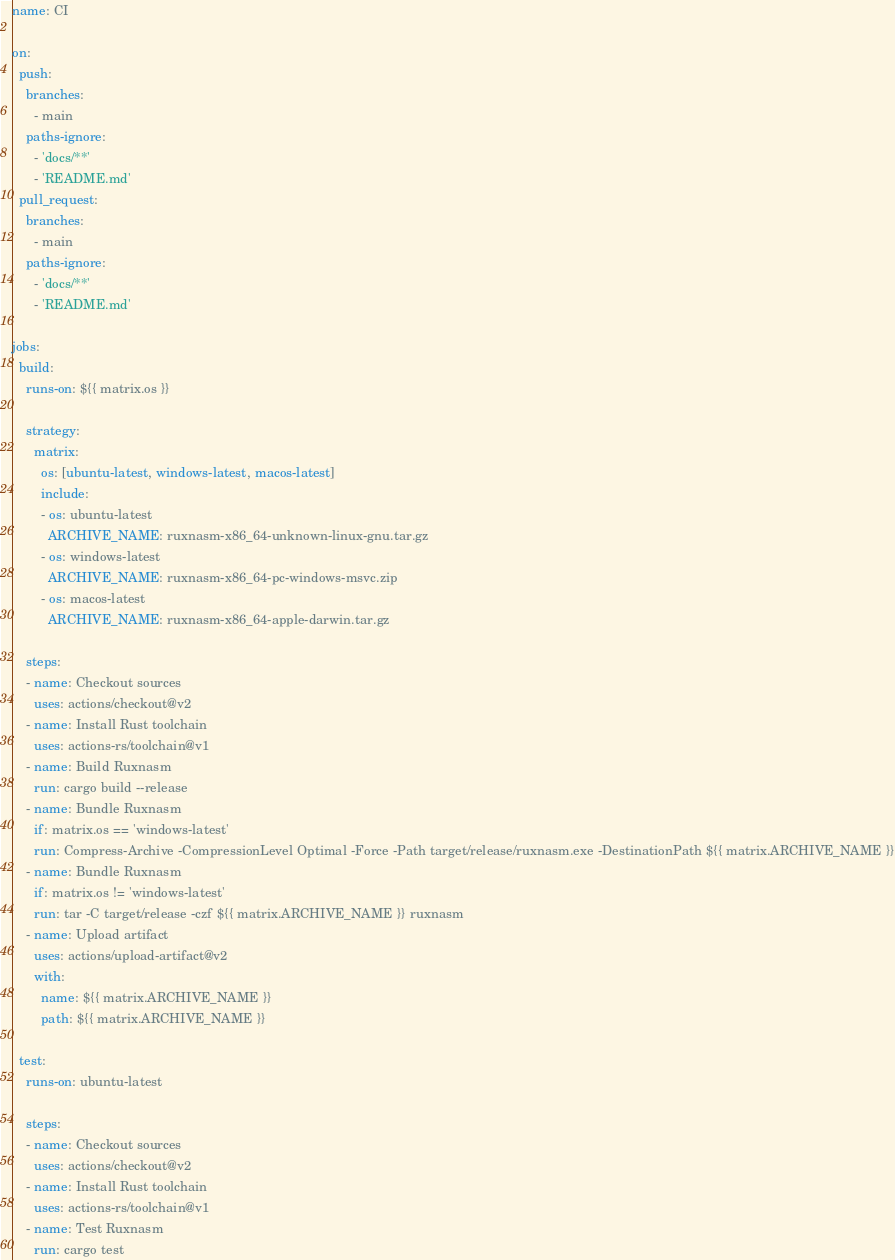<code> <loc_0><loc_0><loc_500><loc_500><_YAML_>name: CI

on:
  push:
    branches:
      - main
    paths-ignore:
      - 'docs/**'
      - 'README.md'
  pull_request:
    branches:
      - main
    paths-ignore:
      - 'docs/**'
      - 'README.md'

jobs:
  build:
    runs-on: ${{ matrix.os }}

    strategy:
      matrix:
        os: [ubuntu-latest, windows-latest, macos-latest]
        include:
        - os: ubuntu-latest
          ARCHIVE_NAME: ruxnasm-x86_64-unknown-linux-gnu.tar.gz
        - os: windows-latest
          ARCHIVE_NAME: ruxnasm-x86_64-pc-windows-msvc.zip
        - os: macos-latest
          ARCHIVE_NAME: ruxnasm-x86_64-apple-darwin.tar.gz

    steps:
    - name: Checkout sources
      uses: actions/checkout@v2
    - name: Install Rust toolchain
      uses: actions-rs/toolchain@v1
    - name: Build Ruxnasm
      run: cargo build --release
    - name: Bundle Ruxnasm
      if: matrix.os == 'windows-latest'
      run: Compress-Archive -CompressionLevel Optimal -Force -Path target/release/ruxnasm.exe -DestinationPath ${{ matrix.ARCHIVE_NAME }}
    - name: Bundle Ruxnasm
      if: matrix.os != 'windows-latest'
      run: tar -C target/release -czf ${{ matrix.ARCHIVE_NAME }} ruxnasm
    - name: Upload artifact
      uses: actions/upload-artifact@v2
      with:
        name: ${{ matrix.ARCHIVE_NAME }}
        path: ${{ matrix.ARCHIVE_NAME }}

  test:
    runs-on: ubuntu-latest
    
    steps:
    - name: Checkout sources
      uses: actions/checkout@v2
    - name: Install Rust toolchain
      uses: actions-rs/toolchain@v1
    - name: Test Ruxnasm
      run: cargo test
</code> 